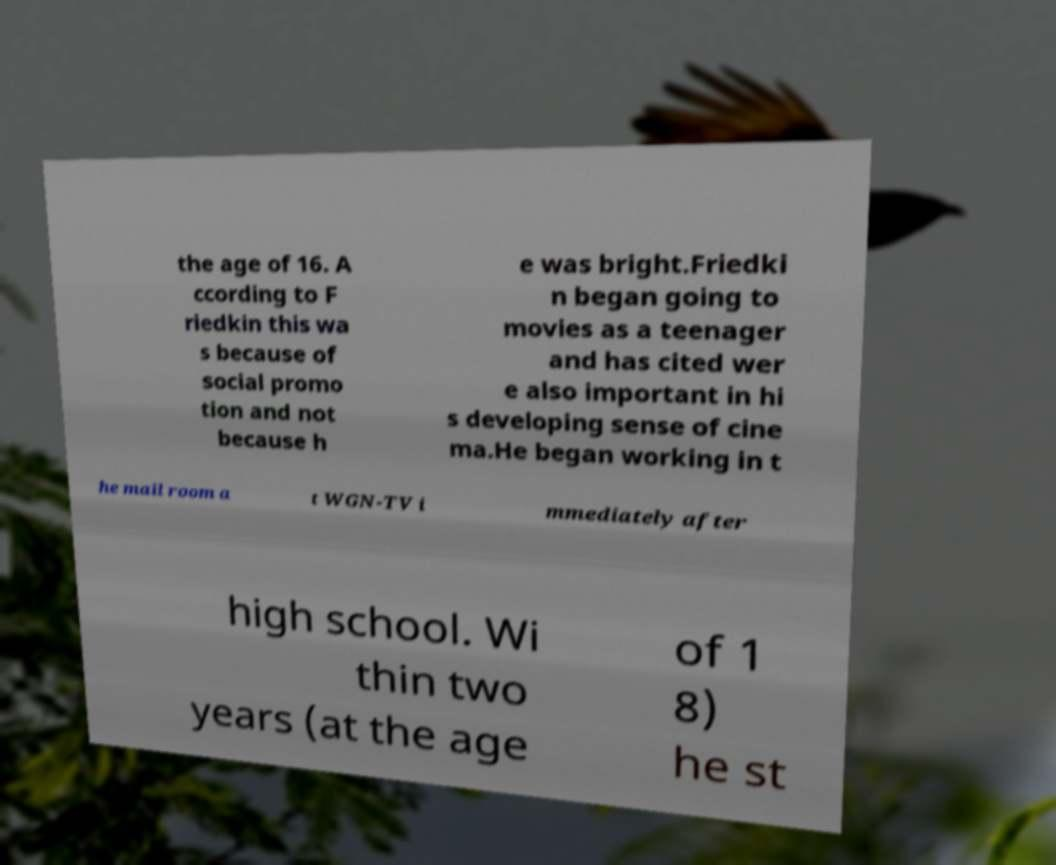For documentation purposes, I need the text within this image transcribed. Could you provide that? the age of 16. A ccording to F riedkin this wa s because of social promo tion and not because h e was bright.Friedki n began going to movies as a teenager and has cited wer e also important in hi s developing sense of cine ma.He began working in t he mail room a t WGN-TV i mmediately after high school. Wi thin two years (at the age of 1 8) he st 